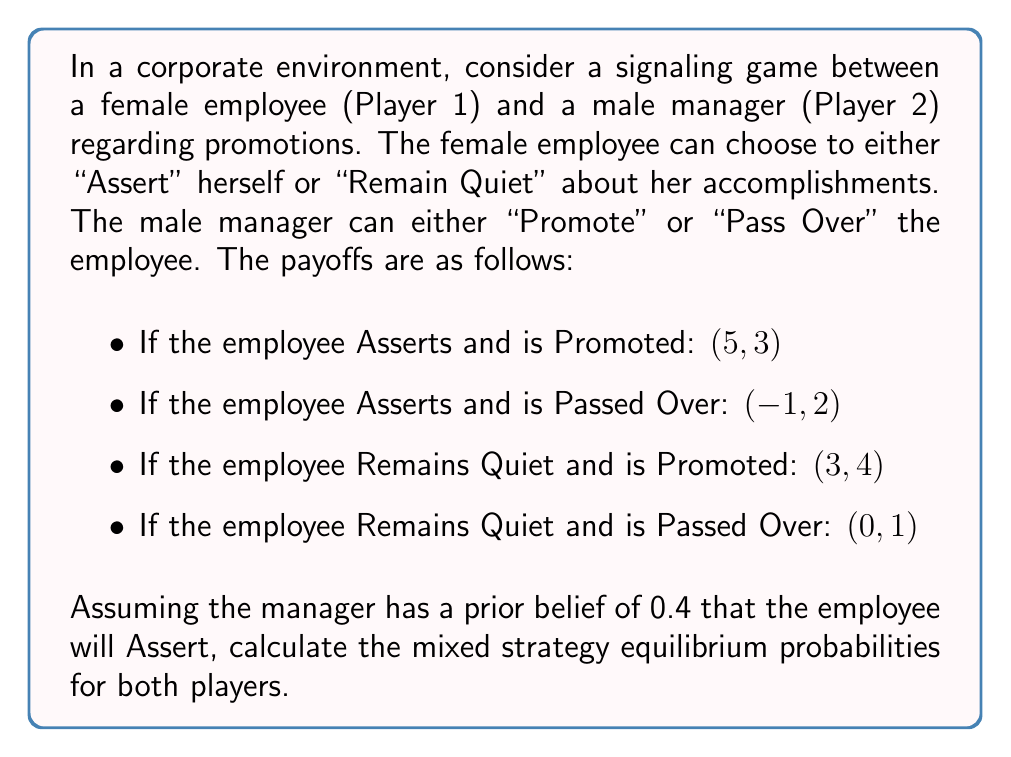Give your solution to this math problem. To solve this signaling game and find the mixed strategy equilibrium, we'll follow these steps:

1) Let's define our variables:
   $p$ = probability that the employee Asserts
   $q$ = probability that the manager Promotes

2) For a mixed strategy equilibrium, each player must be indifferent between their pure strategies. We'll set up equations based on this principle.

3) For the employee (Player 1):
   Expected utility of Asserting = Expected utility of Remaining Quiet
   $5q + (-1)(1-q) = 3q + 0(1-q)$
   $5q - 1 + q = 3q$
   $6q - 1 = 3q$
   $3q = 1$
   $q = \frac{1}{3}$

4) For the manager (Player 2):
   Expected utility of Promoting = Expected utility of Passing Over
   $3p + 4(1-p) = 2p + 1(1-p)$
   $3p + 4 - 4p = 2p + 1 - p$
   $4 - p = 1 + p$
   $3 = 2p$
   $p = \frac{3}{2}$

5) However, $p = \frac{3}{2}$ is not a valid probability. This means the manager's best response is always to Pass Over, regardless of the employee's strategy.

6) Given this, we need to recalculate the employee's strategy. If the manager always Passes Over $(q = 0)$, then:

   Utility of Asserting = -1
   Utility of Remaining Quiet = 0

   The employee will always choose to Remain Quiet.

7) Now, we need to check if this pure strategy for the employee (always Remain Quiet) is consistent with the manager's strategy to always Pass Over.

   If $p = 0$ (employee always Remains Quiet):
   Utility of Promoting = 4
   Utility of Passing Over = 1

   This contradicts our earlier conclusion that the manager would always Pass Over.

8) Therefore, we must return to a mixed strategy for the manager. The manager will mix their strategy to make the employee indifferent between Asserting and Remaining Quiet:

   $5q - 1(1-q) = 3q + 0(1-q)$
   $5q - 1 + q = 3q$
   $6q - 1 = 3q$
   $3q = 1$
   $q = \frac{1}{3}$

9) Given this, the employee will mix their strategy to make the manager indifferent between Promoting and Passing Over:

   $3p + 4(1-p) = 2p + 1(1-p)$
   $3p + 4 - 4p = 2p + 1 - p$
   $-p + 4 = p + 1$
   $3 = 2p$
   $p = \frac{3}{2}$

10) However, $p = \frac{3}{2}$ is still not a valid probability. The closest valid probability is $p = 1$, which means the employee will always Assert.

Therefore, the mixed strategy equilibrium is:
- Employee (Player 1): Assert with probability 1 (always Assert)
- Manager (Player 2): Promote with probability $\frac{1}{3}$, Pass Over with probability $\frac{2}{3}$
Answer: The mixed strategy equilibrium probabilities are:
Employee: Assert with probability 1
Manager: Promote with probability $\frac{1}{3}$, Pass Over with probability $\frac{2}{3}$ 